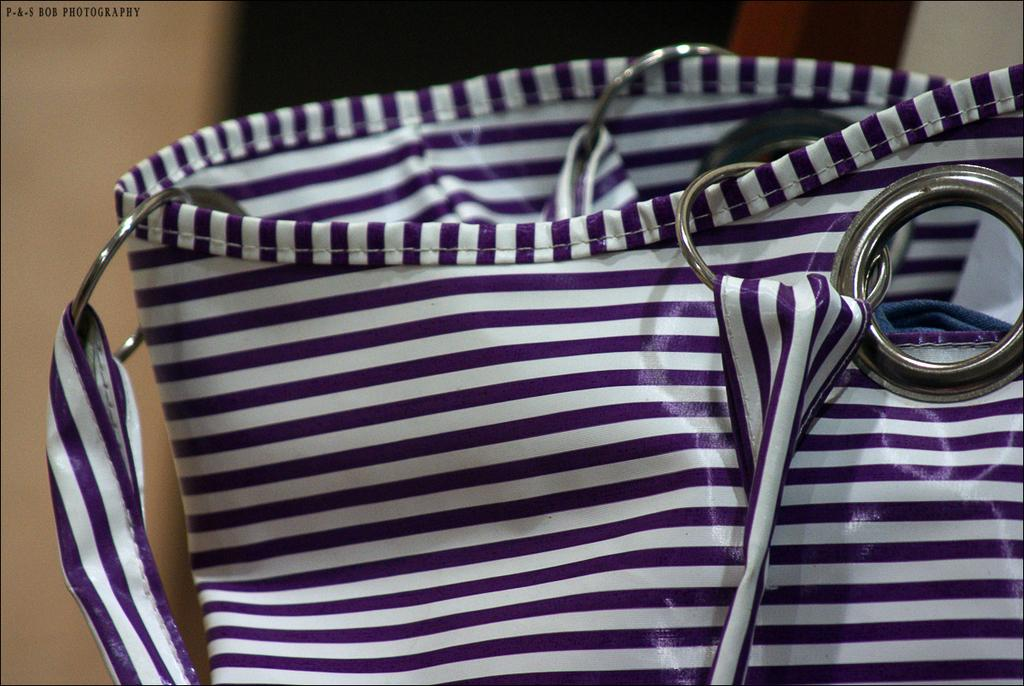What object is present in the image? There is a bag in the image. What colors and pattern are featured on the bag? The bag has violet and white color stripes. What additional feature can be seen on the bag? The bag has rings. How many family members are visible in the image? There are no family members present in the image; it only features a bag. What type of credit card is being used to purchase the bag in the image? There is no credit card or purchase being depicted in the image; it only shows a bag with violet and white stripes and rings. 